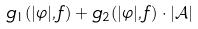<formula> <loc_0><loc_0><loc_500><loc_500>g _ { 1 } ( | \varphi | , f ) + g _ { 2 } ( | \varphi | , f ) \cdot | \mathcal { A } |</formula> 